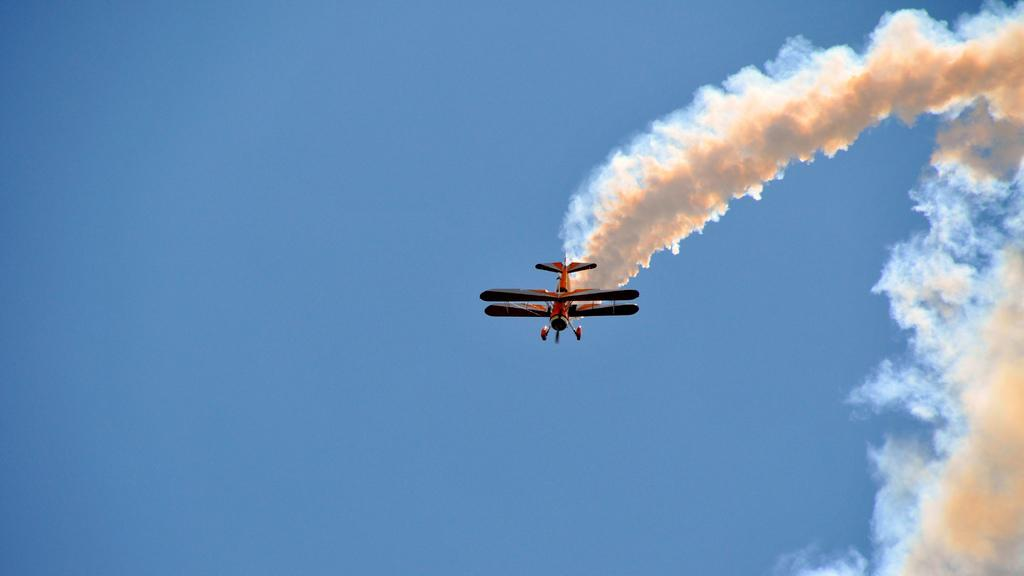What can be seen in the background of the image? There is a sky in the picture. What is present in the sky? There is smoke visible in the picture. What is the main subject of the image? There is an airplane in the picture. What type of books can be seen in the airplane's cargo hold? There are no books visible in the image, as it only features an airplane, sky, and smoke. 